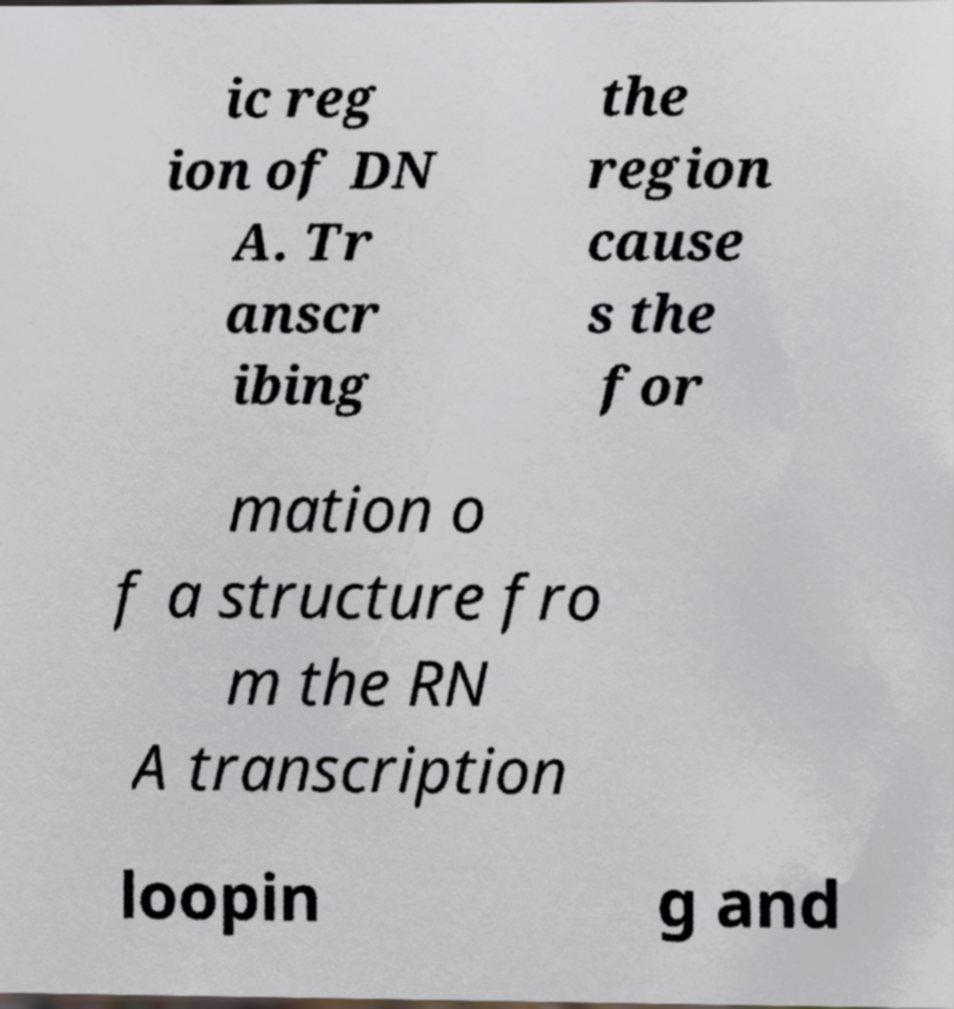Please read and relay the text visible in this image. What does it say? ic reg ion of DN A. Tr anscr ibing the region cause s the for mation o f a structure fro m the RN A transcription loopin g and 